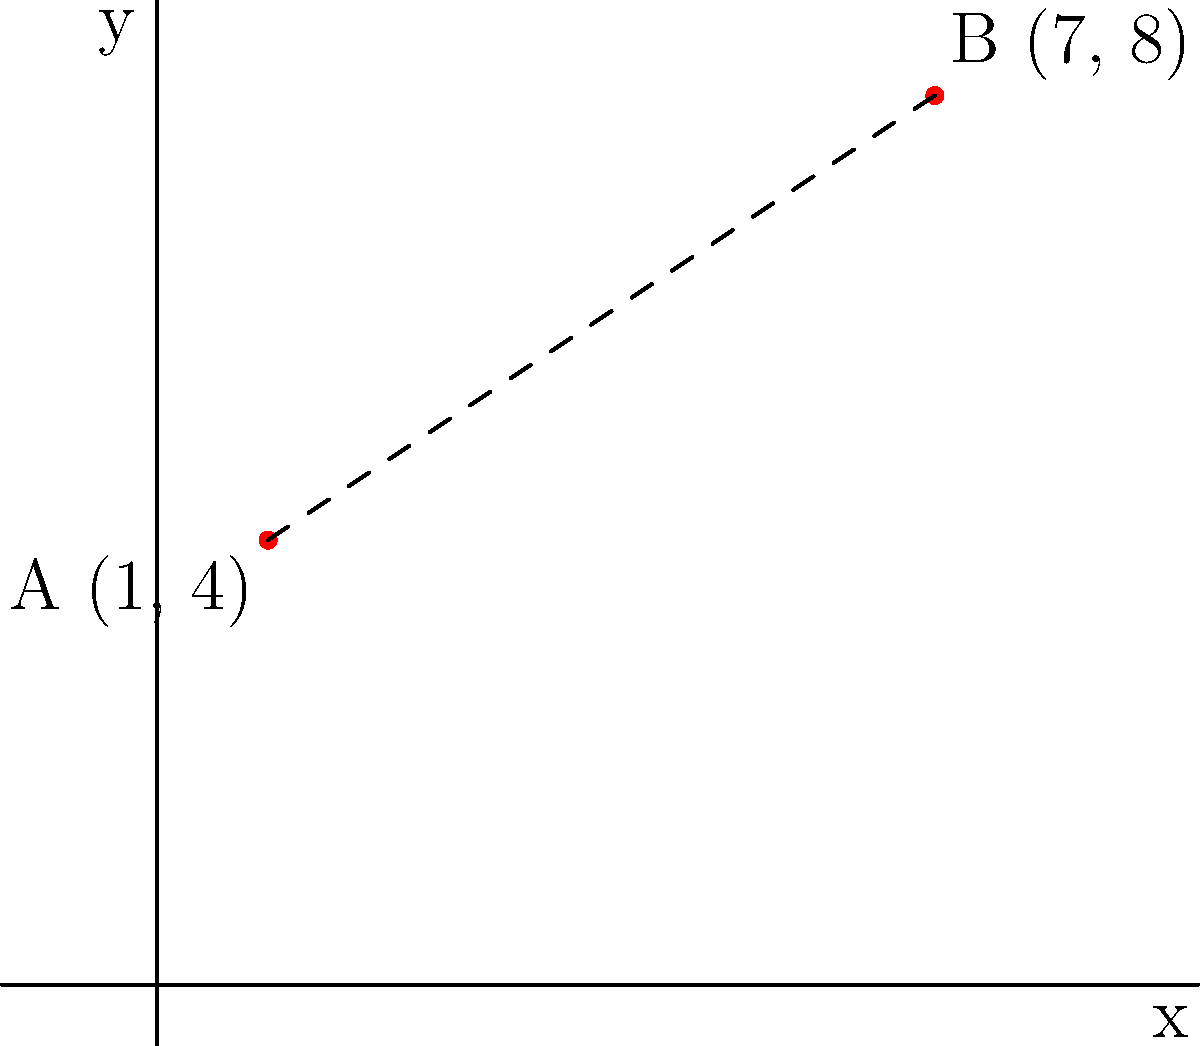In a Danish football stadium, two lucky points A(1, 4) and B(7, 8) are marked on the pitch. If these points represent the jersey numbers of your favorite players (1 and 7) and their birth dates (4th and 8th), what is the distance between these two superstitious points? Round your answer to two decimal places. To find the distance between two points on a Cartesian plane, we use the distance formula:

$$ d = \sqrt{(x_2 - x_1)^2 + (y_2 - y_1)^2} $$

Where $(x_1, y_1)$ are the coordinates of the first point and $(x_2, y_2)$ are the coordinates of the second point.

Let's plug in the values:
$x_1 = 1$, $y_1 = 4$ (Point A)
$x_2 = 7$, $y_2 = 8$ (Point B)

$$ d = \sqrt{(7 - 1)^2 + (8 - 4)^2} $$

$$ d = \sqrt{6^2 + 4^2} $$

$$ d = \sqrt{36 + 16} $$

$$ d = \sqrt{52} $$

$$ d \approx 7.21 $$

Rounding to two decimal places, we get 7.21.
Answer: 7.21 